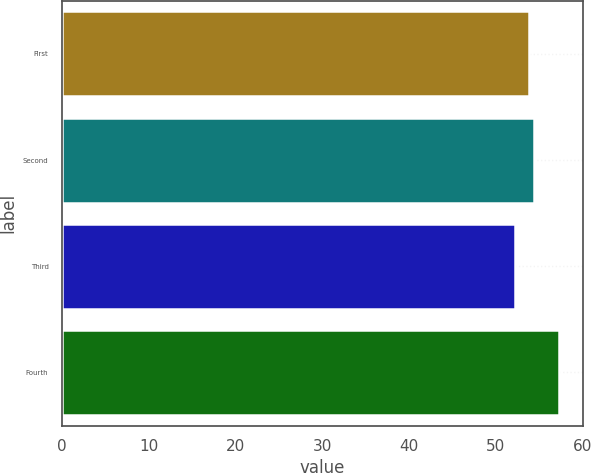Convert chart to OTSL. <chart><loc_0><loc_0><loc_500><loc_500><bar_chart><fcel>First<fcel>Second<fcel>Third<fcel>Fourth<nl><fcel>53.86<fcel>54.37<fcel>52.15<fcel>57.21<nl></chart> 